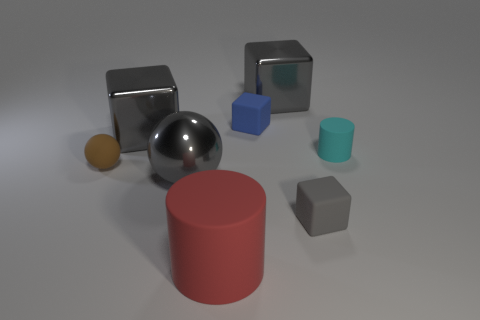Can you guess the relative weight of these objects? While the image doesn't provide actual weight measurements, we can make educated guesses based on their apparent materials and sizes. The metal-looking cubes and sphere are likely to be the heaviest, given that metals are typically denser than plastics or rubbers. The blue plastic-looking cube may be lighter than the metallic objects but heavier than the rubber ones. The red and gray rubber-like objects might be the lightest due to the material's lower density. However, if the metal-looking objects are hollow or made of a light metallic alloy, their weights could be closer to that of the plastic and rubber objects. 